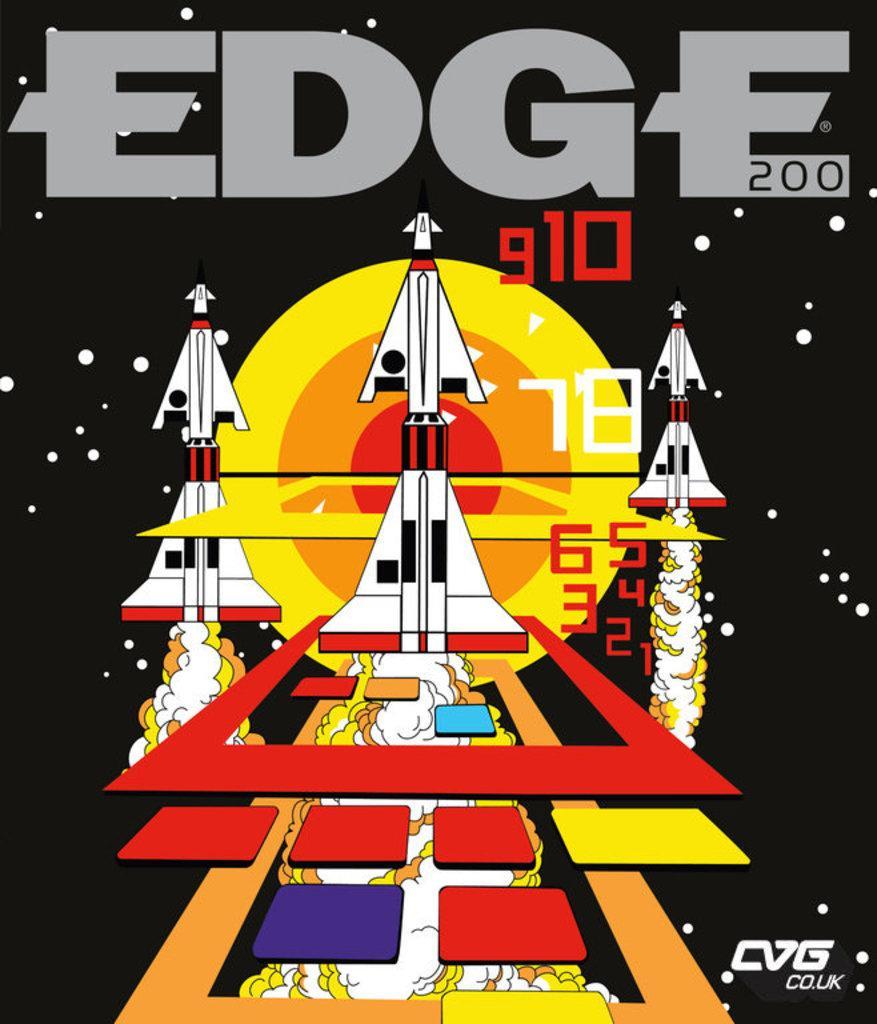Can you describe this image briefly? This image is consists of an edge video game magazines. 